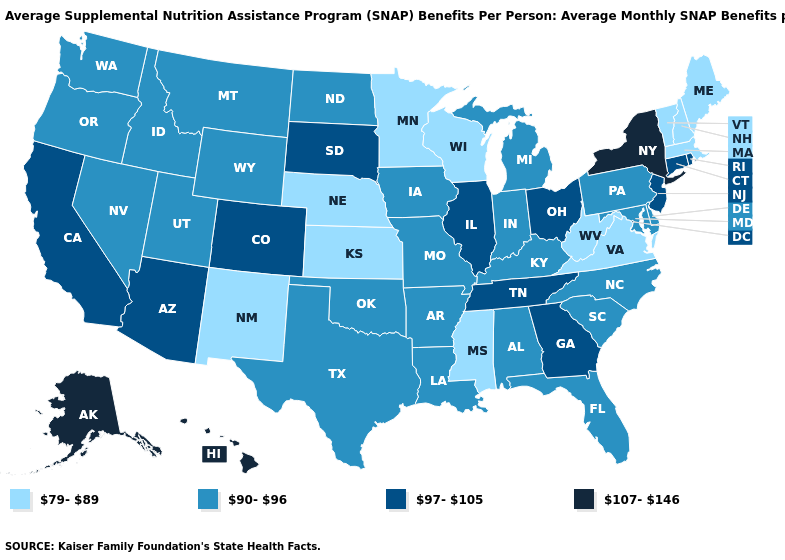What is the lowest value in states that border Florida?
Short answer required. 90-96. Which states have the lowest value in the USA?
Give a very brief answer. Kansas, Maine, Massachusetts, Minnesota, Mississippi, Nebraska, New Hampshire, New Mexico, Vermont, Virginia, West Virginia, Wisconsin. Which states have the lowest value in the USA?
Short answer required. Kansas, Maine, Massachusetts, Minnesota, Mississippi, Nebraska, New Hampshire, New Mexico, Vermont, Virginia, West Virginia, Wisconsin. What is the lowest value in states that border Washington?
Be succinct. 90-96. Name the states that have a value in the range 107-146?
Keep it brief. Alaska, Hawaii, New York. Is the legend a continuous bar?
Keep it brief. No. Among the states that border Wyoming , which have the highest value?
Answer briefly. Colorado, South Dakota. Does Washington have a lower value than South Carolina?
Write a very short answer. No. Name the states that have a value in the range 97-105?
Concise answer only. Arizona, California, Colorado, Connecticut, Georgia, Illinois, New Jersey, Ohio, Rhode Island, South Dakota, Tennessee. What is the value of Maine?
Be succinct. 79-89. Among the states that border Delaware , which have the lowest value?
Be succinct. Maryland, Pennsylvania. Name the states that have a value in the range 79-89?
Write a very short answer. Kansas, Maine, Massachusetts, Minnesota, Mississippi, Nebraska, New Hampshire, New Mexico, Vermont, Virginia, West Virginia, Wisconsin. Does Louisiana have the lowest value in the South?
Write a very short answer. No. Name the states that have a value in the range 97-105?
Write a very short answer. Arizona, California, Colorado, Connecticut, Georgia, Illinois, New Jersey, Ohio, Rhode Island, South Dakota, Tennessee. 